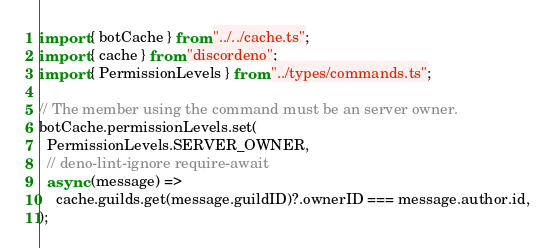<code> <loc_0><loc_0><loc_500><loc_500><_TypeScript_>import { botCache } from "../../cache.ts";
import { cache } from "discordeno";
import { PermissionLevels } from "../types/commands.ts";

// The member using the command must be an server owner.
botCache.permissionLevels.set(
  PermissionLevels.SERVER_OWNER,
  // deno-lint-ignore require-await
  async (message) =>
    cache.guilds.get(message.guildID)?.ownerID === message.author.id,
);
</code> 